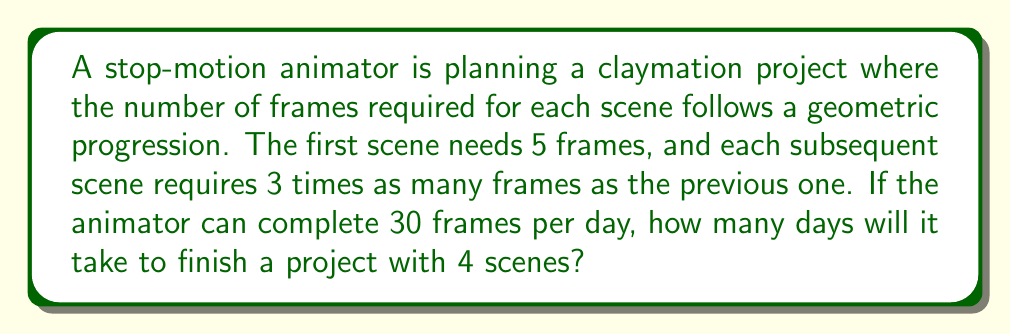Show me your answer to this math problem. Let's approach this step-by-step:

1) First, we need to calculate the number of frames for each scene:
   Scene 1: $5$ frames
   Scene 2: $5 \times 3 = 15$ frames
   Scene 3: $15 \times 3 = 45$ frames
   Scene 4: $45 \times 3 = 135$ frames

2) This forms a geometric sequence with first term $a = 5$ and common ratio $r = 3$. We can verify this using the formula for the nth term of a geometric sequence:
   $a_n = ar^{n-1}$

3) Now, let's calculate the total number of frames:
   $\text{Total frames} = 5 + 15 + 45 + 135 = 200$

4) We can verify this using the formula for the sum of a geometric sequence:
   $$S_n = \frac{a(1-r^n)}{1-r} = \frac{5(1-3^4)}{1-3} = \frac{5(80)}{-2} = -200$$
   (The negative sign appears due to $1-r$ being negative; we take the absolute value)

5) Given that the animator can complete 30 frames per day, we can calculate the number of days required:
   $$\text{Days required} = \frac{\text{Total frames}}{\text{Frames per day}} = \frac{200}{30} = \frac{20}{3} = 6\frac{2}{3}$$

6) Since we can't have a fractional day, we round up to the nearest whole number: 7 days.
Answer: 7 days 